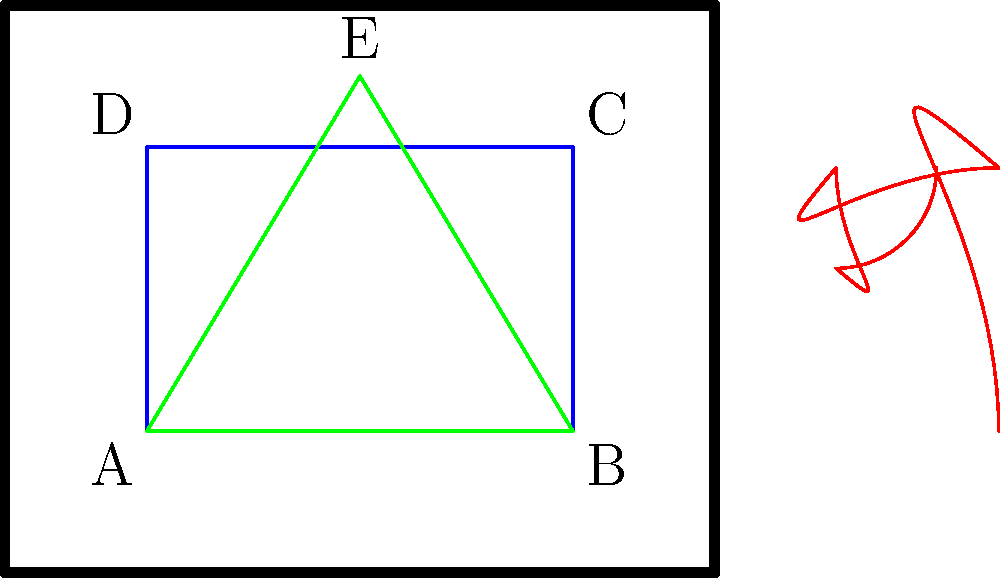In the given Renaissance fresco diagram, identify the geometric shapes and their potential symbolic meanings. How do these shapes contribute to the composition's overall perspective and harmony? 1. Golden Rectangle (ABCD):
   - Identified by the blue rectangle ABCD
   - Ratio of length to width is approximately 1.618 (the golden ratio, $\phi$)
   - Symbolizes divine proportion and aesthetic perfection

2. Golden Spiral:
   - Shown in red, spiraling inward from the largest rectangle
   - Follows the Fibonacci sequence
   - Represents natural growth patterns and divine order

3. Equilateral Triangle (ABE):
   - Depicted in green
   - All sides and angles are equal
   - Often symbolizes the Holy Trinity or spiritual balance

4. Perspective and Harmony:
   - The golden rectangle creates a balanced, pleasing composition
   - The spiral leads the eye through the painting, creating movement
   - The triangle adds stability and directs attention upward

5. Mathematical Relationships:
   - Golden Ratio: $\phi = \frac{1 + \sqrt{5}}{2} \approx 1.618$
   - In the golden rectangle: $\frac{AB}{AD} = \phi$
   - Equilateral triangle: all angles are 60°

These geometric elements work together to create a harmonious composition that reflects Renaissance ideals of proportion, perspective, and divine order. The use of these shapes demonstrates the artist's understanding of mathematics and geometry in art.
Answer: Golden rectangle, golden spiral, equilateral triangle; divine proportion, natural order, Holy Trinity; harmony through mathematical relationships 